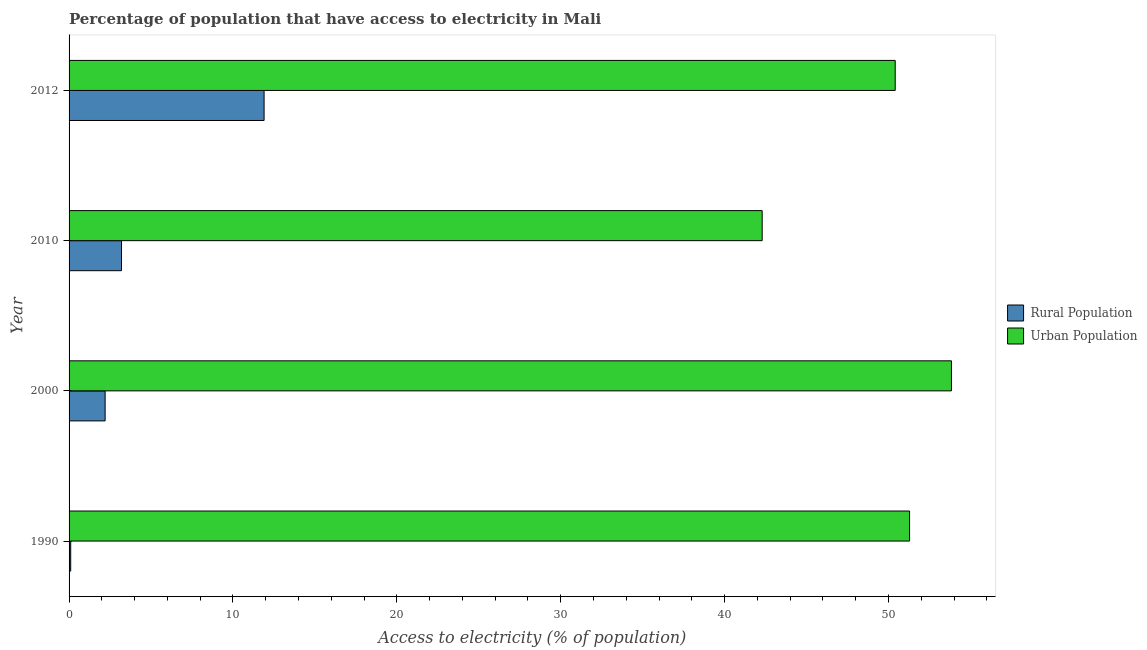Are the number of bars on each tick of the Y-axis equal?
Offer a very short reply. Yes. What is the label of the 4th group of bars from the top?
Your answer should be compact. 1990. In how many cases, is the number of bars for a given year not equal to the number of legend labels?
Keep it short and to the point. 0. What is the percentage of rural population having access to electricity in 2010?
Provide a short and direct response. 3.2. Across all years, what is the maximum percentage of urban population having access to electricity?
Provide a short and direct response. 53.84. In which year was the percentage of rural population having access to electricity minimum?
Give a very brief answer. 1990. What is the total percentage of urban population having access to electricity in the graph?
Your response must be concise. 197.83. What is the difference between the percentage of rural population having access to electricity in 2000 and the percentage of urban population having access to electricity in 2012?
Provide a short and direct response. -48.21. What is the average percentage of urban population having access to electricity per year?
Make the answer very short. 49.46. In the year 2010, what is the difference between the percentage of rural population having access to electricity and percentage of urban population having access to electricity?
Ensure brevity in your answer.  -39.09. What is the ratio of the percentage of urban population having access to electricity in 1990 to that in 2000?
Provide a short and direct response. 0.95. Is the percentage of urban population having access to electricity in 2000 less than that in 2012?
Your answer should be very brief. No. What is the difference between the highest and the second highest percentage of urban population having access to electricity?
Give a very brief answer. 2.56. What is the difference between the highest and the lowest percentage of urban population having access to electricity?
Make the answer very short. 11.55. Is the sum of the percentage of urban population having access to electricity in 1990 and 2012 greater than the maximum percentage of rural population having access to electricity across all years?
Ensure brevity in your answer.  Yes. What does the 1st bar from the top in 2000 represents?
Give a very brief answer. Urban Population. What does the 1st bar from the bottom in 2010 represents?
Your answer should be compact. Rural Population. Are all the bars in the graph horizontal?
Keep it short and to the point. Yes. How many years are there in the graph?
Provide a short and direct response. 4. Does the graph contain grids?
Offer a very short reply. No. How are the legend labels stacked?
Your answer should be compact. Vertical. What is the title of the graph?
Offer a very short reply. Percentage of population that have access to electricity in Mali. Does "Foreign Liabilities" appear as one of the legend labels in the graph?
Make the answer very short. No. What is the label or title of the X-axis?
Give a very brief answer. Access to electricity (% of population). What is the label or title of the Y-axis?
Make the answer very short. Year. What is the Access to electricity (% of population) of Urban Population in 1990?
Your answer should be compact. 51.29. What is the Access to electricity (% of population) in Urban Population in 2000?
Offer a very short reply. 53.84. What is the Access to electricity (% of population) in Rural Population in 2010?
Your answer should be compact. 3.2. What is the Access to electricity (% of population) in Urban Population in 2010?
Ensure brevity in your answer.  42.29. What is the Access to electricity (% of population) of Rural Population in 2012?
Offer a very short reply. 11.9. What is the Access to electricity (% of population) of Urban Population in 2012?
Offer a terse response. 50.41. Across all years, what is the maximum Access to electricity (% of population) in Rural Population?
Provide a succinct answer. 11.9. Across all years, what is the maximum Access to electricity (% of population) of Urban Population?
Ensure brevity in your answer.  53.84. Across all years, what is the minimum Access to electricity (% of population) of Rural Population?
Offer a terse response. 0.1. Across all years, what is the minimum Access to electricity (% of population) in Urban Population?
Your response must be concise. 42.29. What is the total Access to electricity (% of population) in Rural Population in the graph?
Ensure brevity in your answer.  17.4. What is the total Access to electricity (% of population) in Urban Population in the graph?
Give a very brief answer. 197.83. What is the difference between the Access to electricity (% of population) in Urban Population in 1990 and that in 2000?
Keep it short and to the point. -2.56. What is the difference between the Access to electricity (% of population) in Rural Population in 1990 and that in 2010?
Offer a terse response. -3.1. What is the difference between the Access to electricity (% of population) of Urban Population in 1990 and that in 2010?
Keep it short and to the point. 8.99. What is the difference between the Access to electricity (% of population) of Rural Population in 1990 and that in 2012?
Provide a succinct answer. -11.8. What is the difference between the Access to electricity (% of population) of Urban Population in 1990 and that in 2012?
Your answer should be compact. 0.88. What is the difference between the Access to electricity (% of population) in Rural Population in 2000 and that in 2010?
Provide a short and direct response. -1. What is the difference between the Access to electricity (% of population) of Urban Population in 2000 and that in 2010?
Keep it short and to the point. 11.55. What is the difference between the Access to electricity (% of population) of Rural Population in 2000 and that in 2012?
Offer a very short reply. -9.7. What is the difference between the Access to electricity (% of population) in Urban Population in 2000 and that in 2012?
Offer a very short reply. 3.43. What is the difference between the Access to electricity (% of population) in Rural Population in 2010 and that in 2012?
Offer a very short reply. -8.7. What is the difference between the Access to electricity (% of population) of Urban Population in 2010 and that in 2012?
Ensure brevity in your answer.  -8.12. What is the difference between the Access to electricity (% of population) of Rural Population in 1990 and the Access to electricity (% of population) of Urban Population in 2000?
Provide a succinct answer. -53.74. What is the difference between the Access to electricity (% of population) in Rural Population in 1990 and the Access to electricity (% of population) in Urban Population in 2010?
Provide a succinct answer. -42.19. What is the difference between the Access to electricity (% of population) in Rural Population in 1990 and the Access to electricity (% of population) in Urban Population in 2012?
Your answer should be very brief. -50.31. What is the difference between the Access to electricity (% of population) of Rural Population in 2000 and the Access to electricity (% of population) of Urban Population in 2010?
Keep it short and to the point. -40.09. What is the difference between the Access to electricity (% of population) of Rural Population in 2000 and the Access to electricity (% of population) of Urban Population in 2012?
Make the answer very short. -48.21. What is the difference between the Access to electricity (% of population) in Rural Population in 2010 and the Access to electricity (% of population) in Urban Population in 2012?
Give a very brief answer. -47.21. What is the average Access to electricity (% of population) in Rural Population per year?
Your answer should be compact. 4.35. What is the average Access to electricity (% of population) of Urban Population per year?
Your response must be concise. 49.46. In the year 1990, what is the difference between the Access to electricity (% of population) of Rural Population and Access to electricity (% of population) of Urban Population?
Offer a very short reply. -51.19. In the year 2000, what is the difference between the Access to electricity (% of population) in Rural Population and Access to electricity (% of population) in Urban Population?
Offer a very short reply. -51.64. In the year 2010, what is the difference between the Access to electricity (% of population) of Rural Population and Access to electricity (% of population) of Urban Population?
Keep it short and to the point. -39.09. In the year 2012, what is the difference between the Access to electricity (% of population) of Rural Population and Access to electricity (% of population) of Urban Population?
Give a very brief answer. -38.51. What is the ratio of the Access to electricity (% of population) in Rural Population in 1990 to that in 2000?
Keep it short and to the point. 0.05. What is the ratio of the Access to electricity (% of population) in Urban Population in 1990 to that in 2000?
Provide a short and direct response. 0.95. What is the ratio of the Access to electricity (% of population) in Rural Population in 1990 to that in 2010?
Your answer should be compact. 0.03. What is the ratio of the Access to electricity (% of population) of Urban Population in 1990 to that in 2010?
Your answer should be very brief. 1.21. What is the ratio of the Access to electricity (% of population) in Rural Population in 1990 to that in 2012?
Keep it short and to the point. 0.01. What is the ratio of the Access to electricity (% of population) in Urban Population in 1990 to that in 2012?
Provide a short and direct response. 1.02. What is the ratio of the Access to electricity (% of population) in Rural Population in 2000 to that in 2010?
Provide a succinct answer. 0.69. What is the ratio of the Access to electricity (% of population) of Urban Population in 2000 to that in 2010?
Provide a short and direct response. 1.27. What is the ratio of the Access to electricity (% of population) in Rural Population in 2000 to that in 2012?
Offer a very short reply. 0.18. What is the ratio of the Access to electricity (% of population) in Urban Population in 2000 to that in 2012?
Your answer should be compact. 1.07. What is the ratio of the Access to electricity (% of population) of Rural Population in 2010 to that in 2012?
Ensure brevity in your answer.  0.27. What is the ratio of the Access to electricity (% of population) in Urban Population in 2010 to that in 2012?
Make the answer very short. 0.84. What is the difference between the highest and the second highest Access to electricity (% of population) of Urban Population?
Keep it short and to the point. 2.56. What is the difference between the highest and the lowest Access to electricity (% of population) of Rural Population?
Give a very brief answer. 11.8. What is the difference between the highest and the lowest Access to electricity (% of population) in Urban Population?
Provide a short and direct response. 11.55. 